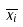Convert formula to latex. <formula><loc_0><loc_0><loc_500><loc_500>\overline { x _ { i } }</formula> 